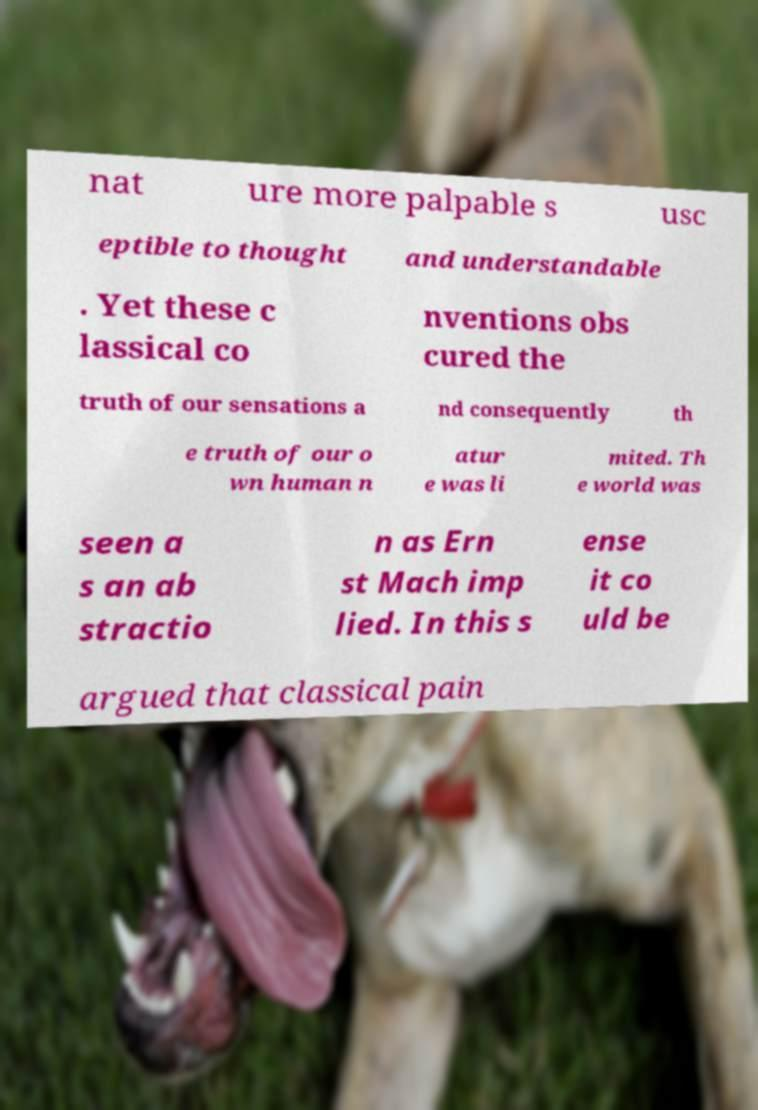Could you extract and type out the text from this image? nat ure more palpable s usc eptible to thought and understandable . Yet these c lassical co nventions obs cured the truth of our sensations a nd consequently th e truth of our o wn human n atur e was li mited. Th e world was seen a s an ab stractio n as Ern st Mach imp lied. In this s ense it co uld be argued that classical pain 